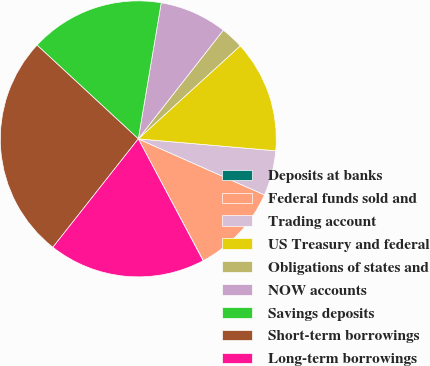<chart> <loc_0><loc_0><loc_500><loc_500><pie_chart><fcel>Deposits at banks<fcel>Federal funds sold and<fcel>Trading account<fcel>US Treasury and federal<fcel>Obligations of states and<fcel>NOW accounts<fcel>Savings deposits<fcel>Short-term borrowings<fcel>Long-term borrowings<nl><fcel>0.04%<fcel>10.53%<fcel>5.28%<fcel>13.15%<fcel>2.66%<fcel>7.91%<fcel>15.77%<fcel>26.27%<fcel>18.4%<nl></chart> 